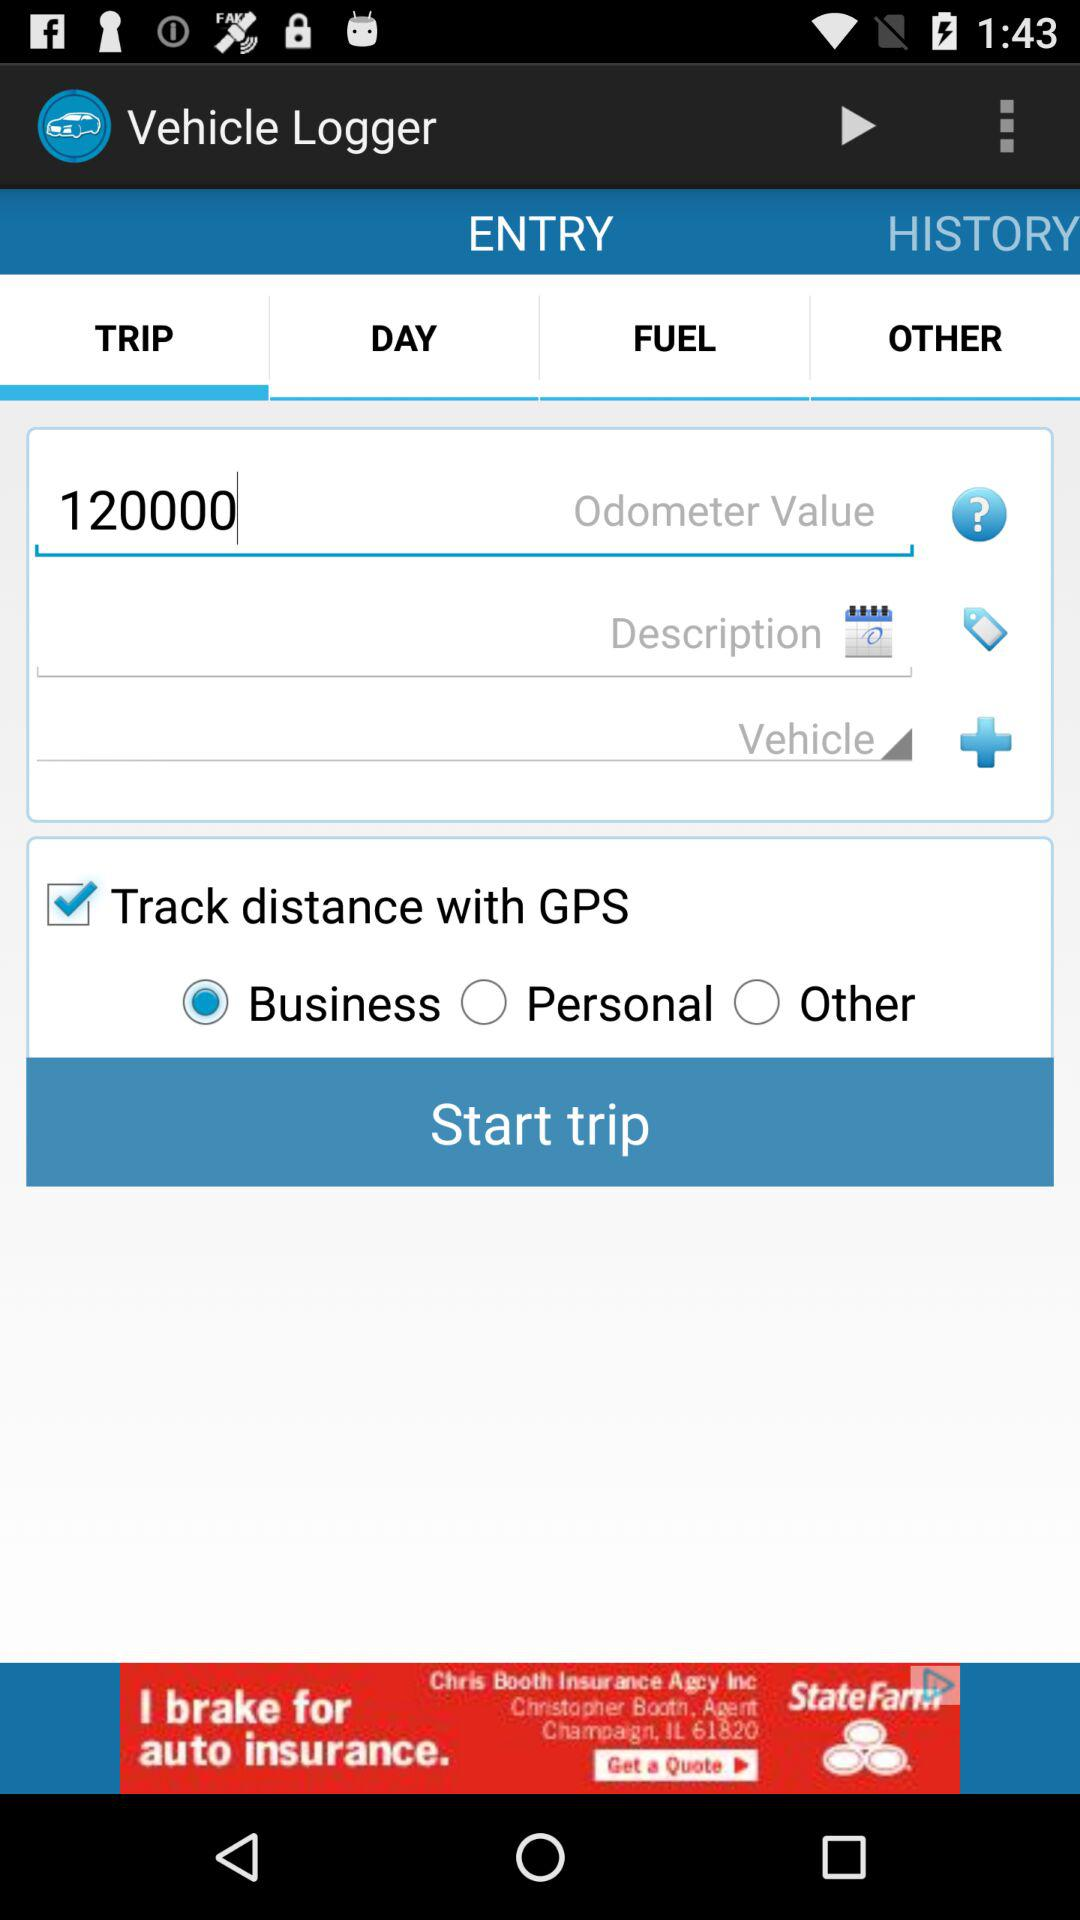What is the odometer value? The odometer value is 120000. 